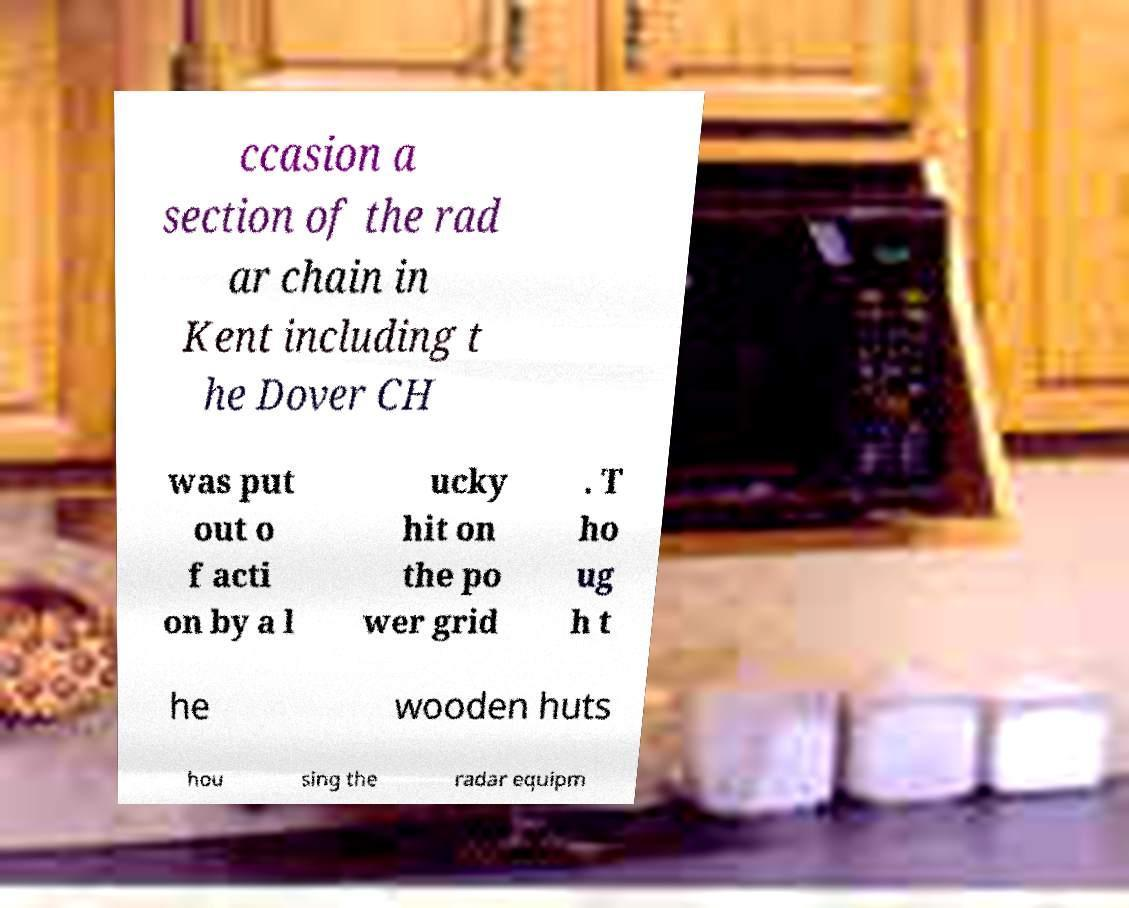Please read and relay the text visible in this image. What does it say? ccasion a section of the rad ar chain in Kent including t he Dover CH was put out o f acti on by a l ucky hit on the po wer grid . T ho ug h t he wooden huts hou sing the radar equipm 